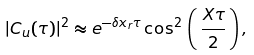<formula> <loc_0><loc_0><loc_500><loc_500>| C _ { u } ( \tau ) | ^ { 2 } \approx e ^ { - \delta x _ { r } \tau } \cos ^ { 2 } \, \left ( \, \frac { X \tau } { 2 } \, \right ) ,</formula> 